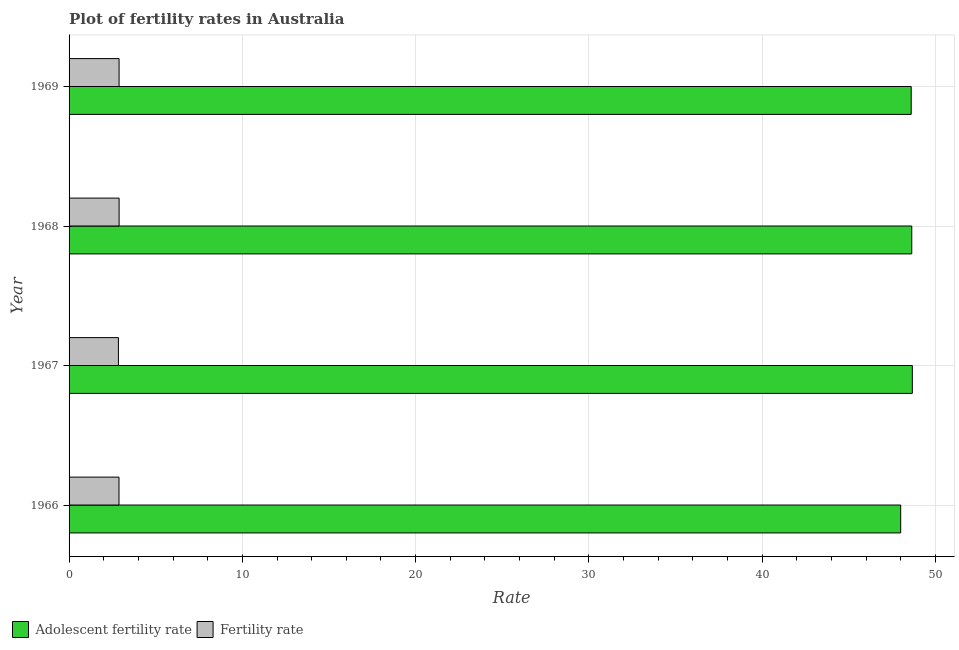How many different coloured bars are there?
Provide a short and direct response. 2. What is the label of the 4th group of bars from the top?
Your response must be concise. 1966. What is the fertility rate in 1967?
Your answer should be compact. 2.85. Across all years, what is the maximum adolescent fertility rate?
Provide a short and direct response. 48.66. Across all years, what is the minimum fertility rate?
Make the answer very short. 2.85. In which year was the fertility rate maximum?
Offer a very short reply. 1968. In which year was the fertility rate minimum?
Offer a terse response. 1967. What is the total fertility rate in the graph?
Provide a short and direct response. 11.5. What is the difference between the adolescent fertility rate in 1966 and that in 1969?
Offer a very short reply. -0.61. What is the difference between the adolescent fertility rate in 1967 and the fertility rate in 1969?
Provide a short and direct response. 45.78. What is the average adolescent fertility rate per year?
Offer a very short reply. 48.47. In the year 1966, what is the difference between the fertility rate and adolescent fertility rate?
Keep it short and to the point. -45.11. What is the ratio of the adolescent fertility rate in 1968 to that in 1969?
Give a very brief answer. 1. What is the difference between the highest and the second highest fertility rate?
Ensure brevity in your answer.  0. What is the difference between the highest and the lowest fertility rate?
Keep it short and to the point. 0.04. What does the 2nd bar from the top in 1967 represents?
Ensure brevity in your answer.  Adolescent fertility rate. What does the 2nd bar from the bottom in 1966 represents?
Keep it short and to the point. Fertility rate. What is the difference between two consecutive major ticks on the X-axis?
Make the answer very short. 10. Does the graph contain grids?
Keep it short and to the point. Yes. How many legend labels are there?
Make the answer very short. 2. What is the title of the graph?
Your answer should be compact. Plot of fertility rates in Australia. Does "Foreign Liabilities" appear as one of the legend labels in the graph?
Provide a succinct answer. No. What is the label or title of the X-axis?
Provide a succinct answer. Rate. What is the Rate of Adolescent fertility rate in 1966?
Provide a short and direct response. 47.99. What is the Rate in Fertility rate in 1966?
Provide a succinct answer. 2.88. What is the Rate of Adolescent fertility rate in 1967?
Ensure brevity in your answer.  48.66. What is the Rate in Fertility rate in 1967?
Offer a very short reply. 2.85. What is the Rate of Adolescent fertility rate in 1968?
Provide a succinct answer. 48.63. What is the Rate of Fertility rate in 1968?
Provide a short and direct response. 2.89. What is the Rate of Adolescent fertility rate in 1969?
Your response must be concise. 48.6. What is the Rate of Fertility rate in 1969?
Make the answer very short. 2.89. Across all years, what is the maximum Rate in Adolescent fertility rate?
Give a very brief answer. 48.66. Across all years, what is the maximum Rate in Fertility rate?
Offer a terse response. 2.89. Across all years, what is the minimum Rate of Adolescent fertility rate?
Make the answer very short. 47.99. Across all years, what is the minimum Rate in Fertility rate?
Your answer should be compact. 2.85. What is the total Rate of Adolescent fertility rate in the graph?
Give a very brief answer. 193.88. What is the total Rate of Fertility rate in the graph?
Your answer should be very brief. 11.5. What is the difference between the Rate in Adolescent fertility rate in 1966 and that in 1967?
Offer a very short reply. -0.67. What is the difference between the Rate in Fertility rate in 1966 and that in 1967?
Make the answer very short. 0.03. What is the difference between the Rate in Adolescent fertility rate in 1966 and that in 1968?
Your answer should be very brief. -0.64. What is the difference between the Rate of Fertility rate in 1966 and that in 1968?
Provide a short and direct response. -0.01. What is the difference between the Rate in Adolescent fertility rate in 1966 and that in 1969?
Your answer should be compact. -0.61. What is the difference between the Rate of Fertility rate in 1966 and that in 1969?
Offer a very short reply. -0.01. What is the difference between the Rate of Adolescent fertility rate in 1967 and that in 1968?
Offer a very short reply. 0.03. What is the difference between the Rate in Fertility rate in 1967 and that in 1968?
Keep it short and to the point. -0.04. What is the difference between the Rate of Adolescent fertility rate in 1967 and that in 1969?
Make the answer very short. 0.06. What is the difference between the Rate in Fertility rate in 1967 and that in 1969?
Offer a terse response. -0.04. What is the difference between the Rate in Adolescent fertility rate in 1968 and that in 1969?
Offer a very short reply. 0.03. What is the difference between the Rate of Fertility rate in 1968 and that in 1969?
Offer a very short reply. 0. What is the difference between the Rate in Adolescent fertility rate in 1966 and the Rate in Fertility rate in 1967?
Ensure brevity in your answer.  45.14. What is the difference between the Rate in Adolescent fertility rate in 1966 and the Rate in Fertility rate in 1968?
Offer a terse response. 45.1. What is the difference between the Rate in Adolescent fertility rate in 1966 and the Rate in Fertility rate in 1969?
Keep it short and to the point. 45.1. What is the difference between the Rate in Adolescent fertility rate in 1967 and the Rate in Fertility rate in 1968?
Your answer should be compact. 45.77. What is the difference between the Rate of Adolescent fertility rate in 1967 and the Rate of Fertility rate in 1969?
Provide a short and direct response. 45.78. What is the difference between the Rate of Adolescent fertility rate in 1968 and the Rate of Fertility rate in 1969?
Make the answer very short. 45.74. What is the average Rate in Adolescent fertility rate per year?
Ensure brevity in your answer.  48.47. What is the average Rate in Fertility rate per year?
Your response must be concise. 2.88. In the year 1966, what is the difference between the Rate in Adolescent fertility rate and Rate in Fertility rate?
Your answer should be compact. 45.11. In the year 1967, what is the difference between the Rate of Adolescent fertility rate and Rate of Fertility rate?
Your answer should be compact. 45.81. In the year 1968, what is the difference between the Rate of Adolescent fertility rate and Rate of Fertility rate?
Offer a terse response. 45.74. In the year 1969, what is the difference between the Rate of Adolescent fertility rate and Rate of Fertility rate?
Offer a terse response. 45.71. What is the ratio of the Rate in Adolescent fertility rate in 1966 to that in 1967?
Provide a succinct answer. 0.99. What is the ratio of the Rate in Fertility rate in 1966 to that in 1967?
Give a very brief answer. 1.01. What is the ratio of the Rate in Adolescent fertility rate in 1966 to that in 1968?
Your answer should be very brief. 0.99. What is the ratio of the Rate in Fertility rate in 1966 to that in 1968?
Make the answer very short. 1. What is the ratio of the Rate of Adolescent fertility rate in 1966 to that in 1969?
Your answer should be compact. 0.99. What is the ratio of the Rate of Fertility rate in 1966 to that in 1969?
Make the answer very short. 1. What is the ratio of the Rate of Adolescent fertility rate in 1967 to that in 1968?
Make the answer very short. 1. What is the ratio of the Rate in Fertility rate in 1967 to that in 1968?
Ensure brevity in your answer.  0.99. What is the ratio of the Rate in Fertility rate in 1967 to that in 1969?
Offer a terse response. 0.99. What is the ratio of the Rate in Adolescent fertility rate in 1968 to that in 1969?
Make the answer very short. 1. What is the difference between the highest and the second highest Rate of Adolescent fertility rate?
Give a very brief answer. 0.03. What is the difference between the highest and the second highest Rate in Fertility rate?
Offer a terse response. 0. What is the difference between the highest and the lowest Rate of Adolescent fertility rate?
Offer a terse response. 0.67. 